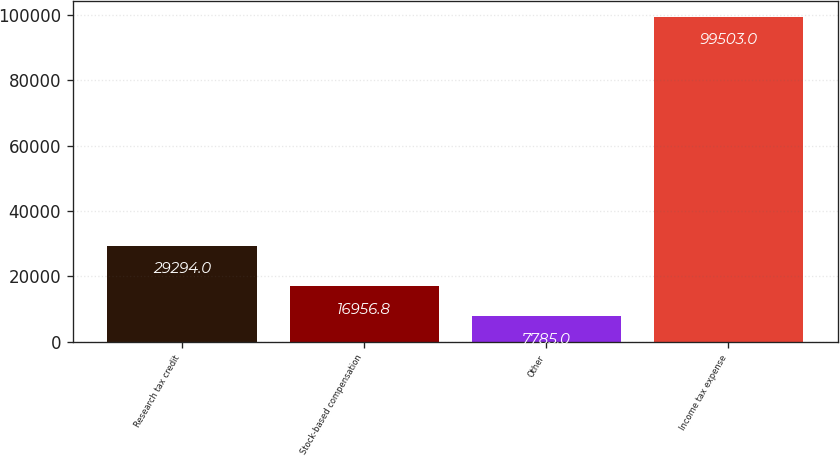<chart> <loc_0><loc_0><loc_500><loc_500><bar_chart><fcel>Research tax credit<fcel>Stock-based compensation<fcel>Other<fcel>Income tax expense<nl><fcel>29294<fcel>16956.8<fcel>7785<fcel>99503<nl></chart> 